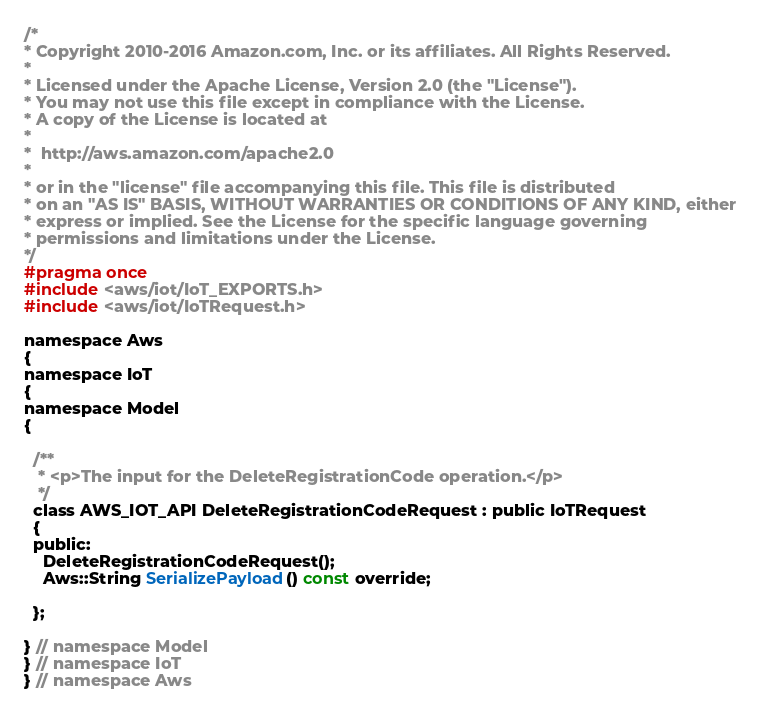<code> <loc_0><loc_0><loc_500><loc_500><_C_>/*
* Copyright 2010-2016 Amazon.com, Inc. or its affiliates. All Rights Reserved.
*
* Licensed under the Apache License, Version 2.0 (the "License").
* You may not use this file except in compliance with the License.
* A copy of the License is located at
*
*  http://aws.amazon.com/apache2.0
*
* or in the "license" file accompanying this file. This file is distributed
* on an "AS IS" BASIS, WITHOUT WARRANTIES OR CONDITIONS OF ANY KIND, either
* express or implied. See the License for the specific language governing
* permissions and limitations under the License.
*/
#pragma once
#include <aws/iot/IoT_EXPORTS.h>
#include <aws/iot/IoTRequest.h>

namespace Aws
{
namespace IoT
{
namespace Model
{

  /**
   * <p>The input for the DeleteRegistrationCode operation.</p>
   */
  class AWS_IOT_API DeleteRegistrationCodeRequest : public IoTRequest
  {
  public:
    DeleteRegistrationCodeRequest();
    Aws::String SerializePayload() const override;

  };

} // namespace Model
} // namespace IoT
} // namespace Aws
</code> 